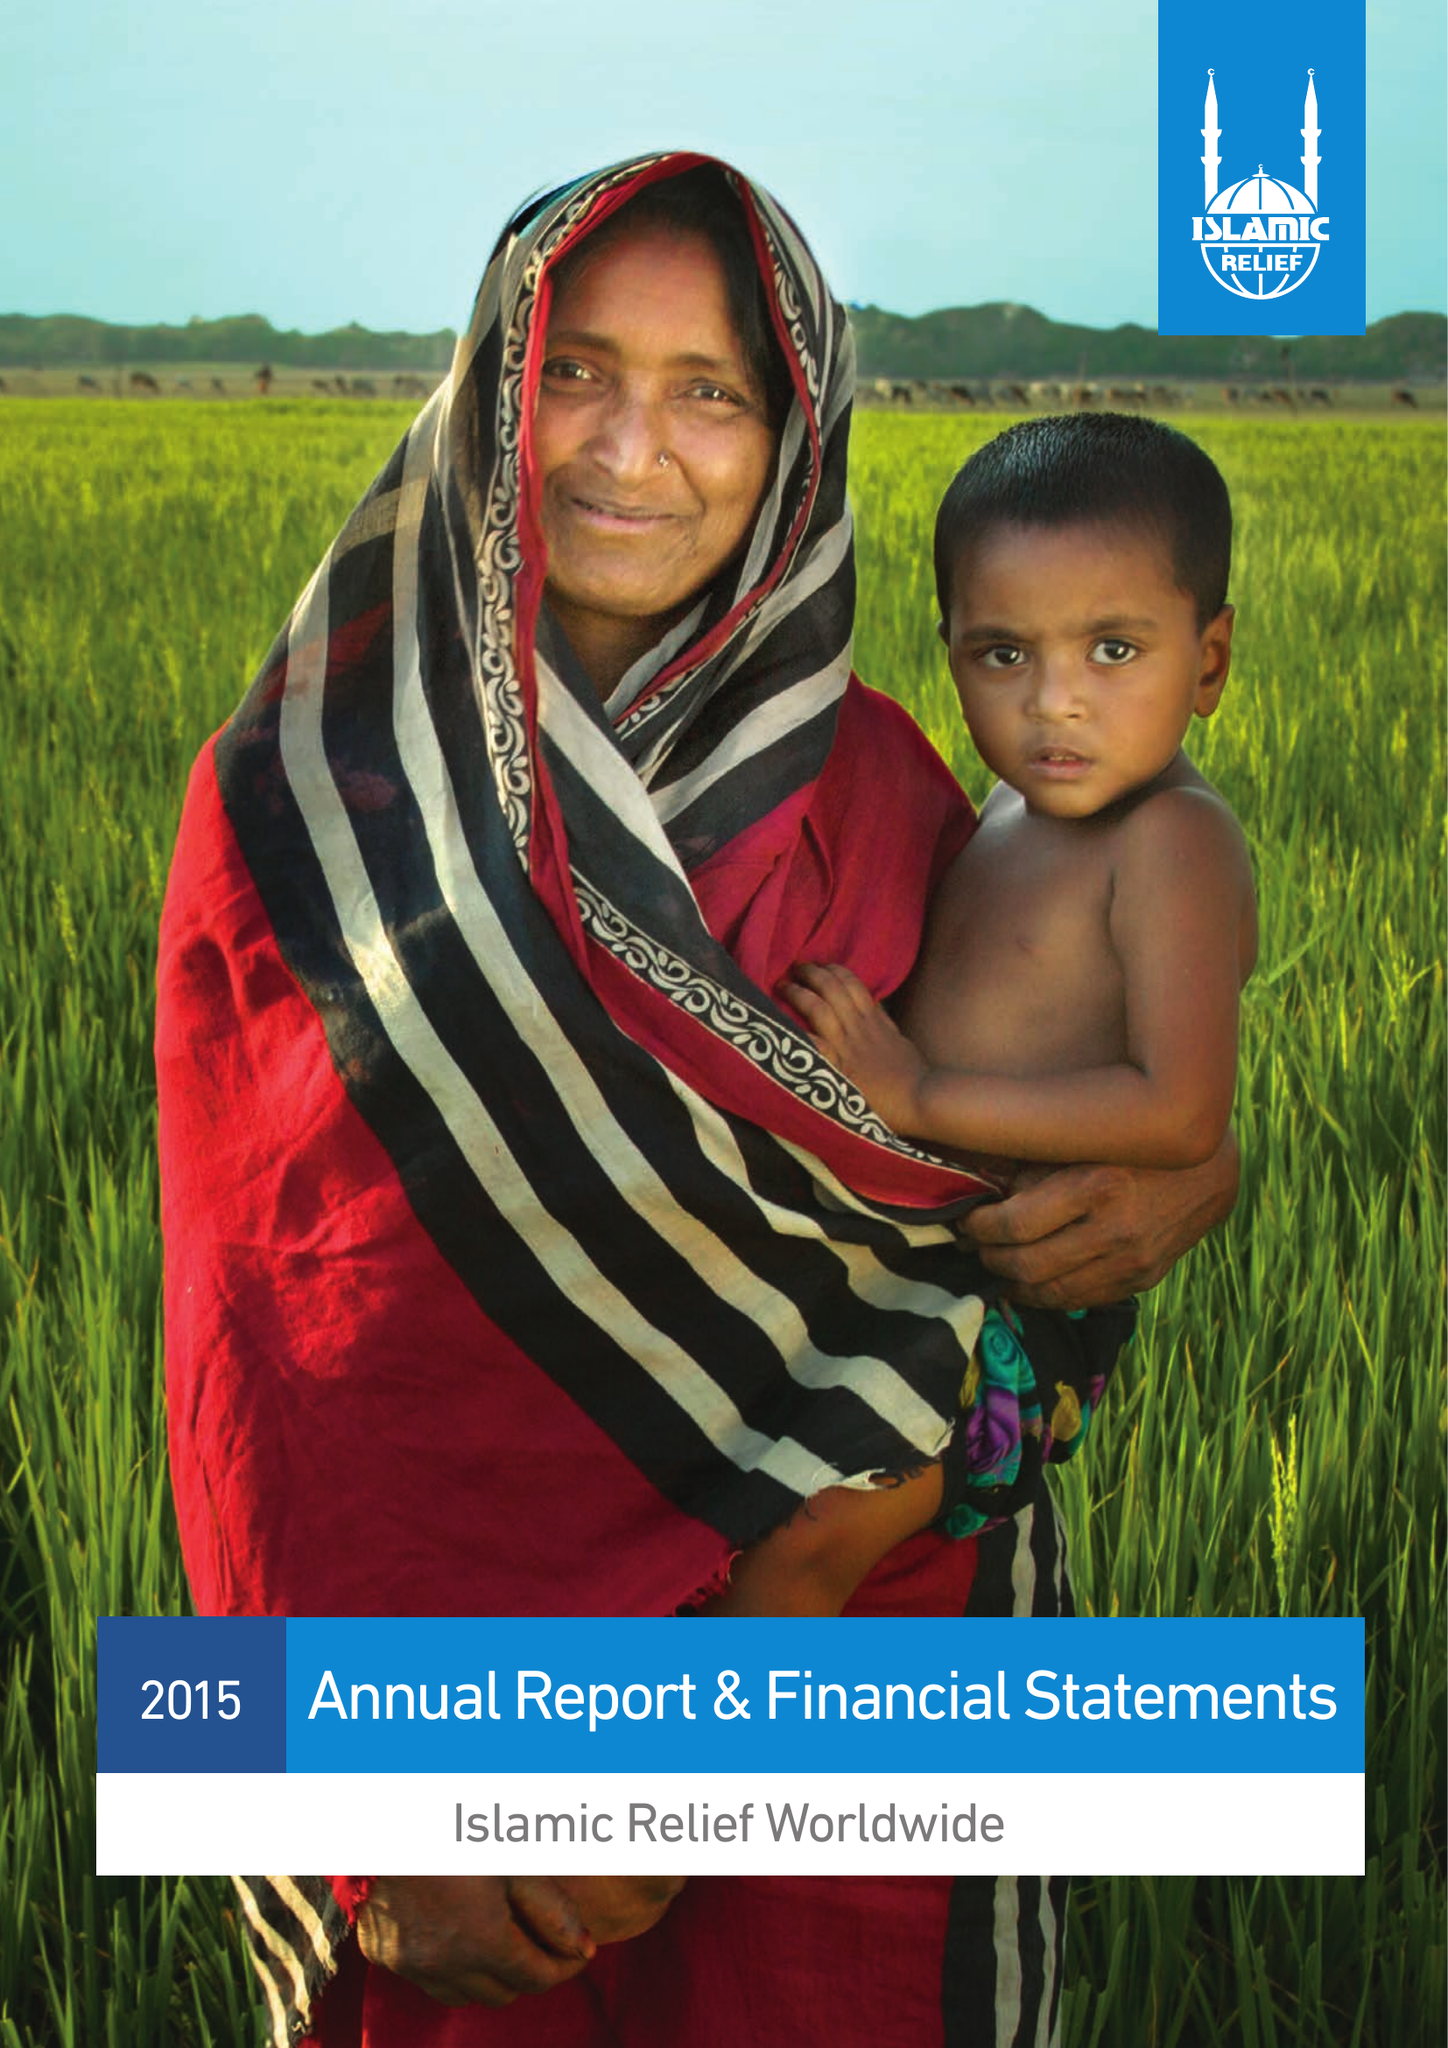What is the value for the address__street_line?
Answer the question using a single word or phrase. 19 REA STREET SOUTH 